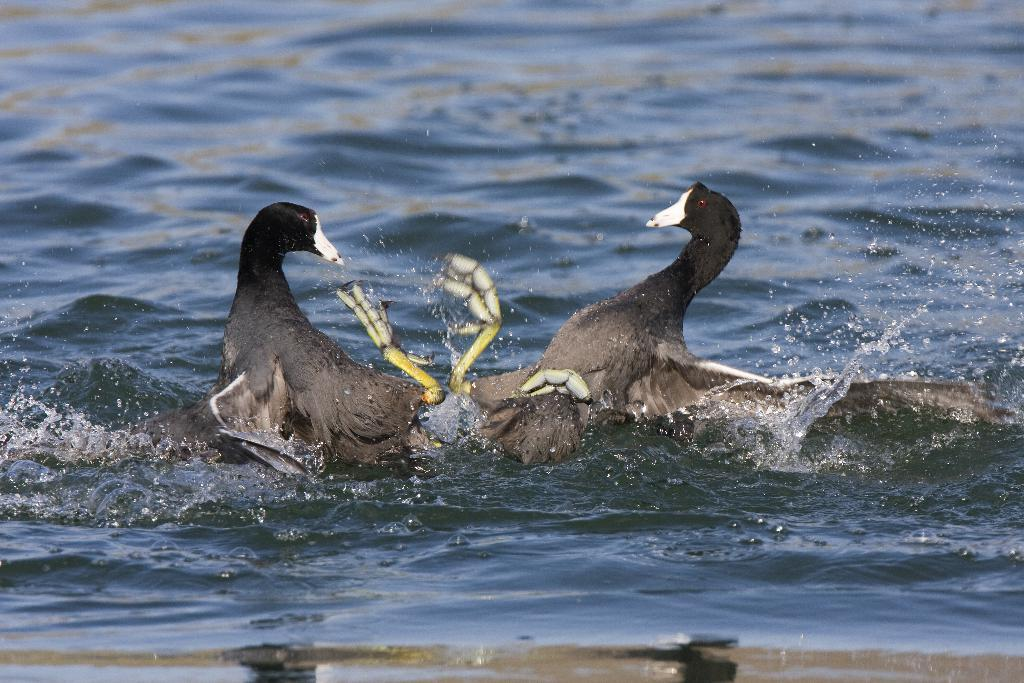How many birds are in the image? There are two birds in the image. What are the birds doing in the image? The birds are playing on the water. What can be seen in the background of the image? The background of the image is water. What type of education can be seen in the image? There is no education present in the image; it features two birds playing on the water with a water background. 